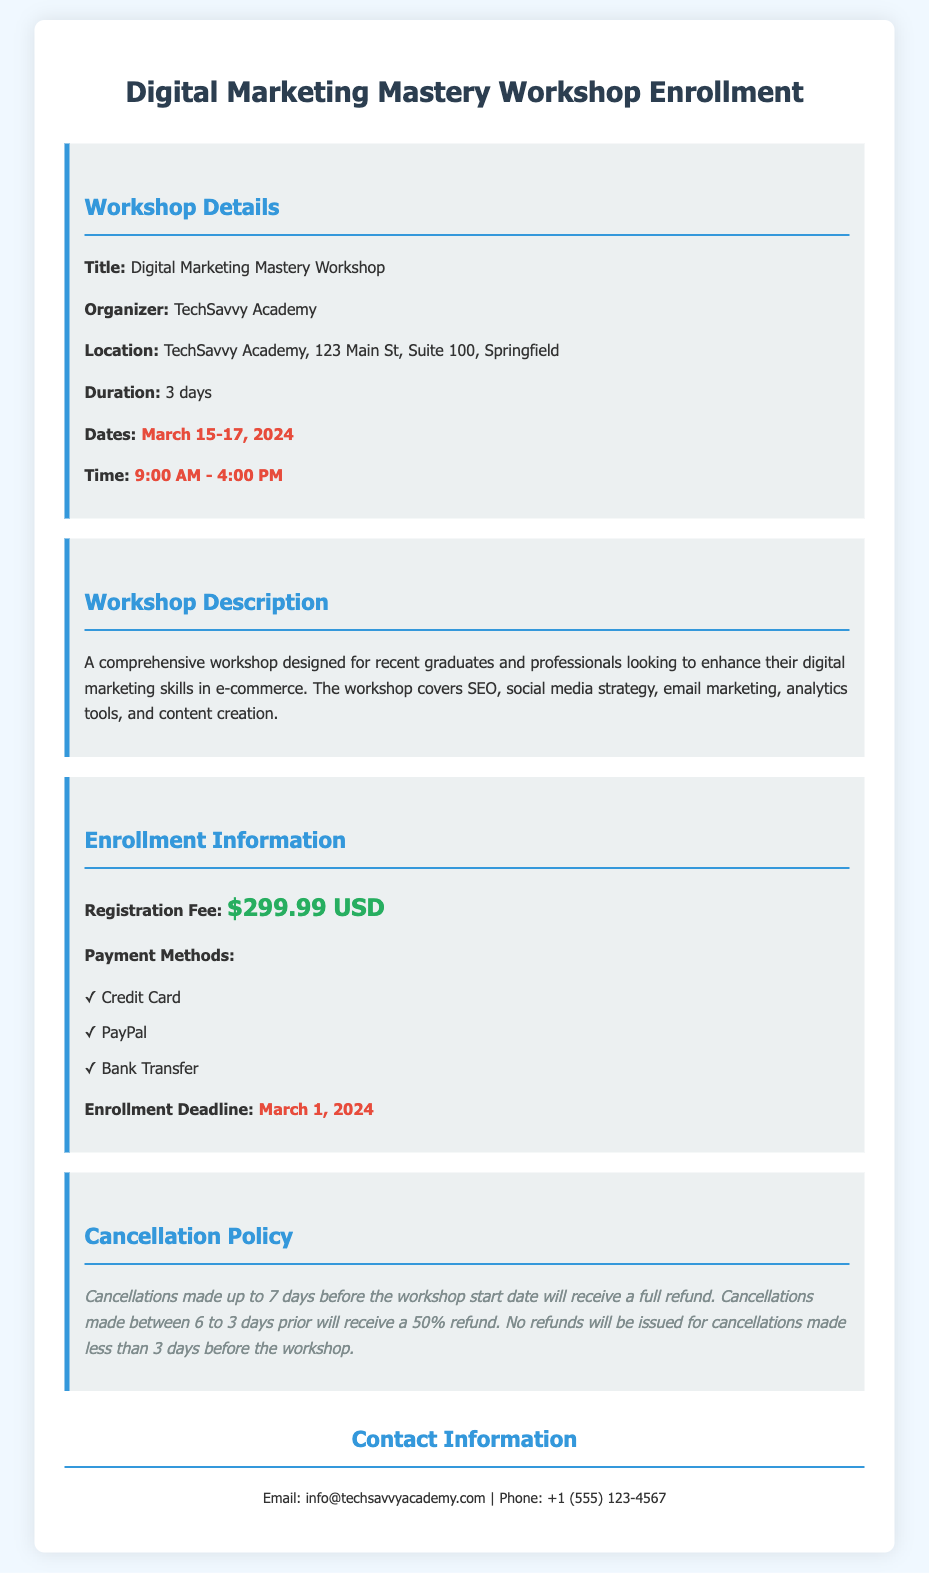What is the title of the workshop? The title of the workshop is mentioned in the "Workshop Details" section as "Digital Marketing Mastery Workshop."
Answer: Digital Marketing Mastery Workshop Who is the organizer of the workshop? The organizer's name is provided in the "Workshop Details" section as "TechSavvy Academy."
Answer: TechSavvy Academy What are the dates of the workshop? The specific dates for the workshop are listed in the "Workshop Details" section as "March 15-17, 2024."
Answer: March 15-17, 2024 What is the registration fee? The registration fee is stated in the "Enrollment Information" section as "$299.99 USD."
Answer: $299.99 USD What is the cancellation policy for refunds? The cancellation policy details are outlined, specifying conditions under which refunds are issued, indicating a full refund up to 7 days, a 50% refund between 6 to 3 days, and no refunds within 3 days before the workshop.
Answer: Full refund up to 7 days What payment methods are available? The document lists several payment options in the "Enrollment Information" section, which include "Credit Card," "PayPal," and "Bank Transfer."
Answer: Credit Card, PayPal, Bank Transfer What is the enrollment deadline? The final date for enrollment is prominently detailed in the "Enrollment Information" section, specified as "March 1, 2024."
Answer: March 1, 2024 What time does the workshop start? The starting time of the workshop is clarified in the "Workshop Details" section as "9:00 AM."
Answer: 9:00 AM How long is the workshop duration? The duration of the workshop is mentioned in the "Workshop Details" section, stating it lasts "3 days."
Answer: 3 days 